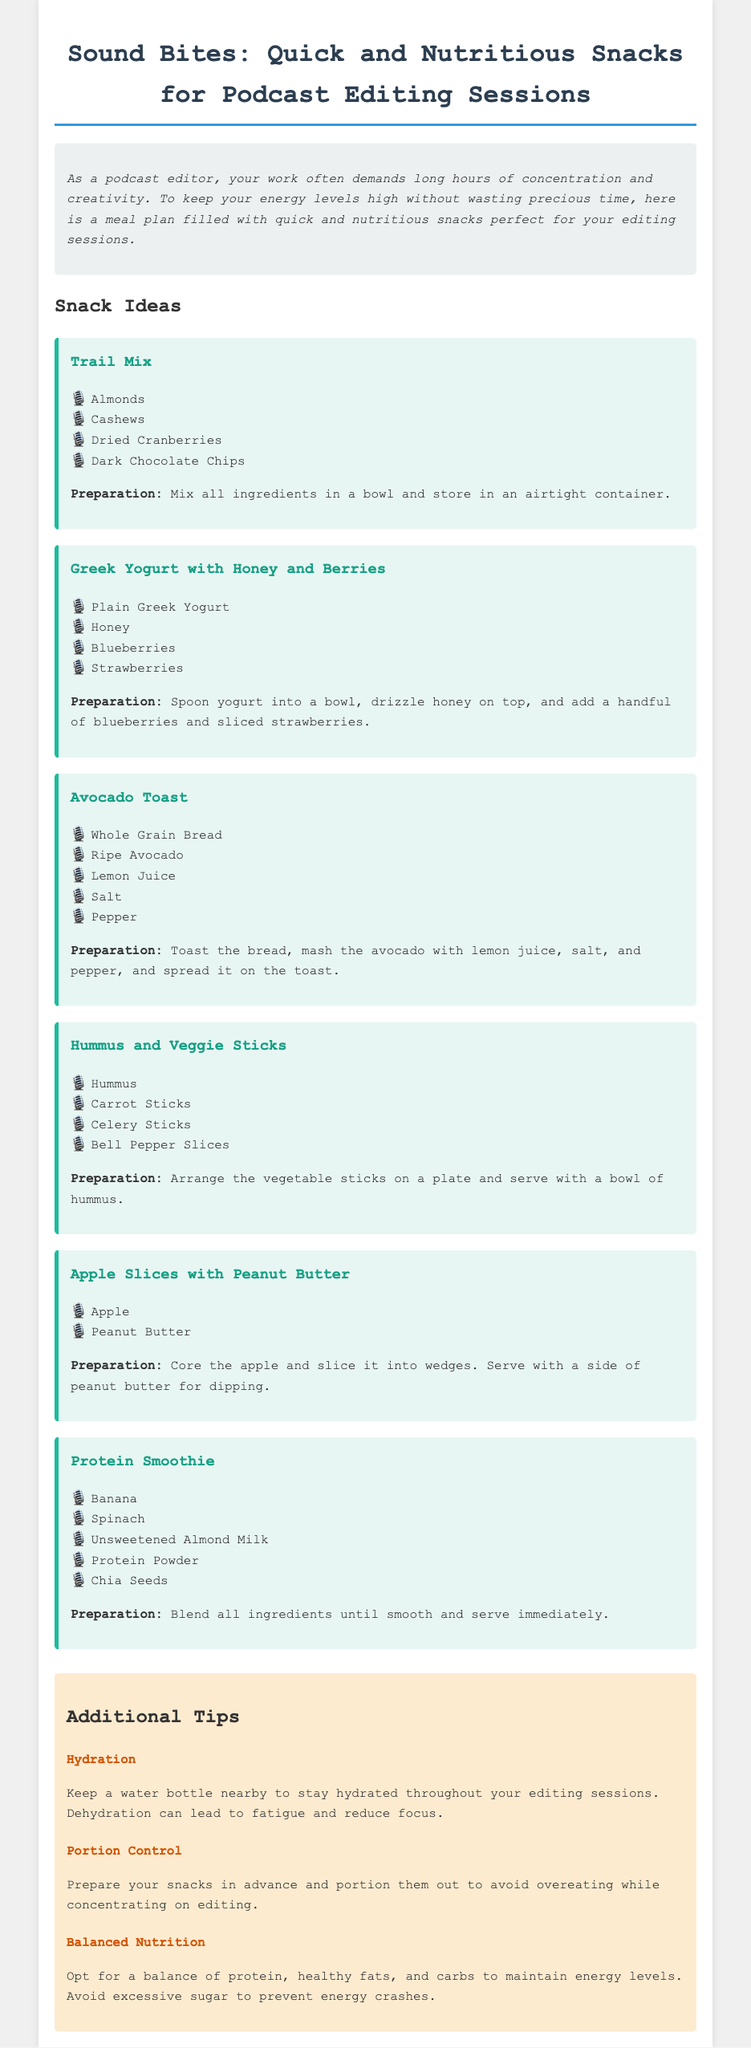What is the title of the document? The title is stated in the header of the document as "Sound Bites: Quick and Nutritious Snacks for Podcast Editing Sessions."
Answer: Sound Bites: Quick and Nutritious Snacks for Podcast Editing Sessions How many snack ideas are listed? The document presents a list of snack ideas in the meal plan section, which contains six distinct snacks.
Answer: 6 What is one ingredient in the Trail Mix? The Trail Mix section lists ingredients, one of which is "Almonds."
Answer: Almonds What is used to prepare Greek Yogurt with Honey and Berries? The Greek Yogurt with Honey and Berries snack includes "Plain Greek Yogurt" as one of its items.
Answer: Plain Greek Yogurt What does the Avocado Toast recipe require to season it? In the Avocado Toast preparation, "Lemon Juice" is mentioned as a seasoning ingredient.
Answer: Lemon Juice Which snack includes carrot sticks? The document specifies that "Hummus and Veggie Sticks" includes carrot sticks.
Answer: Hummus and Veggie Sticks What is one suggested tip for hydration? The tips section includes a suggestion to "Keep a water bottle nearby" for hydration.
Answer: Keep a water bottle nearby What type of bread is recommended for Avocado Toast? The preparation for Avocado Toast mentions "Whole Grain Bread" specifically.
Answer: Whole Grain Bread What is the main purpose of the document? The purpose is stated in the introduction as providing "quick and nutritious snacks perfect for your editing sessions."
Answer: Quick and nutritious snacks perfect for your editing sessions 